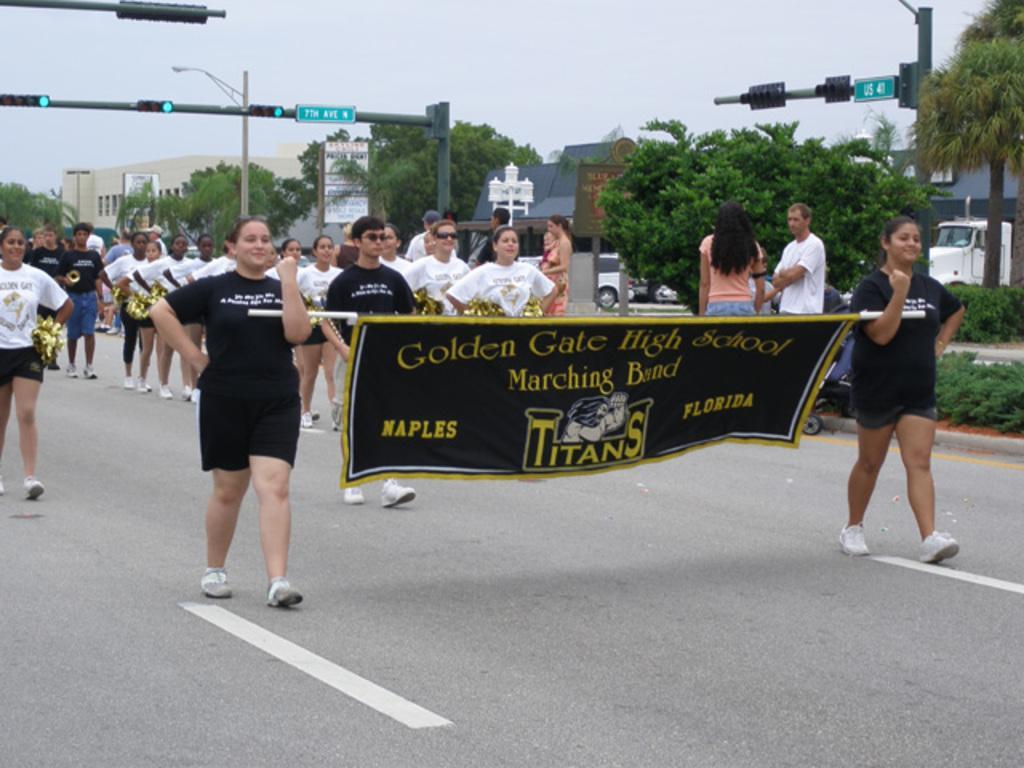How would you summarize this image in a sentence or two? In this image we can see few persons walking on the road, few of them are holding some objects, two persons are holding a banner with some text written on it, there are some trees, vehicles, plants, buildings, also we can see some traffic lights, poles and the sky. 